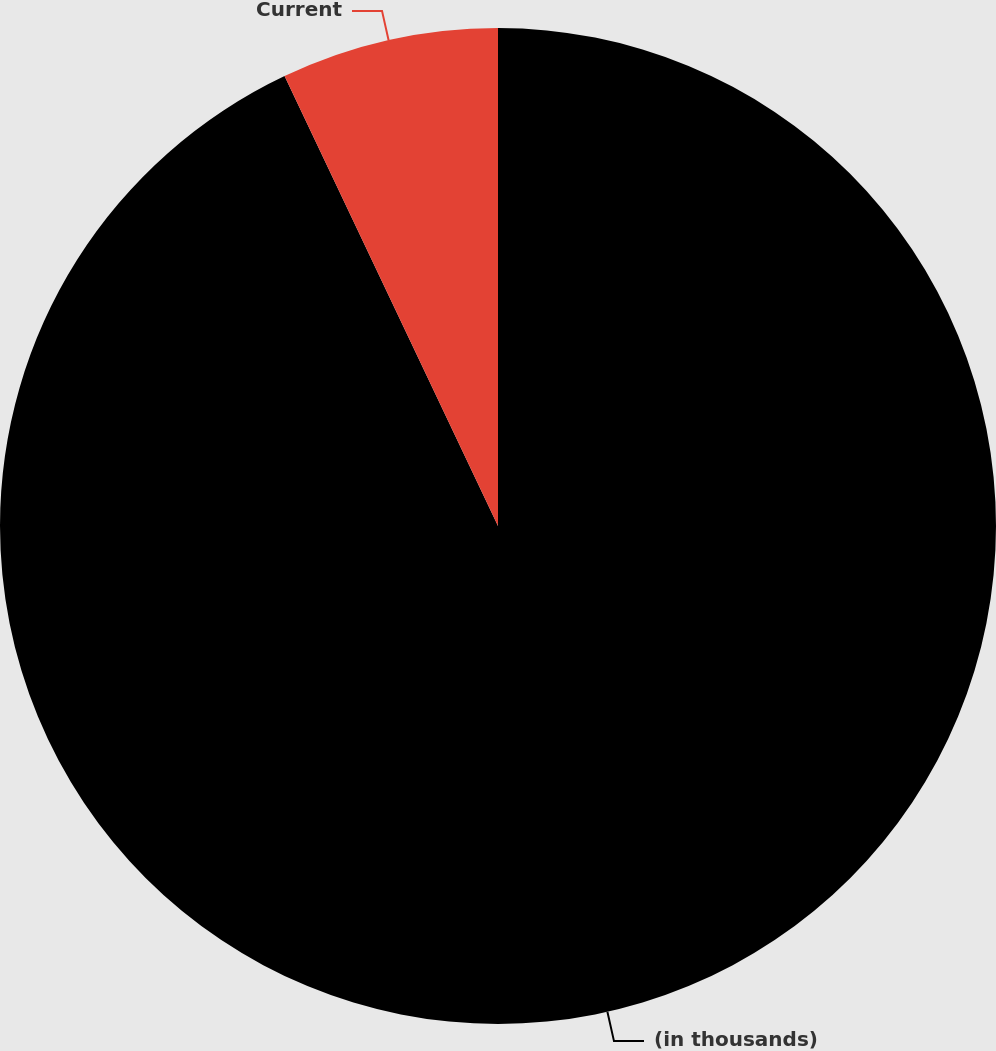Convert chart. <chart><loc_0><loc_0><loc_500><loc_500><pie_chart><fcel>(in thousands)<fcel>Current<nl><fcel>92.95%<fcel>7.05%<nl></chart> 